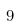Convert formula to latex. <formula><loc_0><loc_0><loc_500><loc_500>9</formula> 